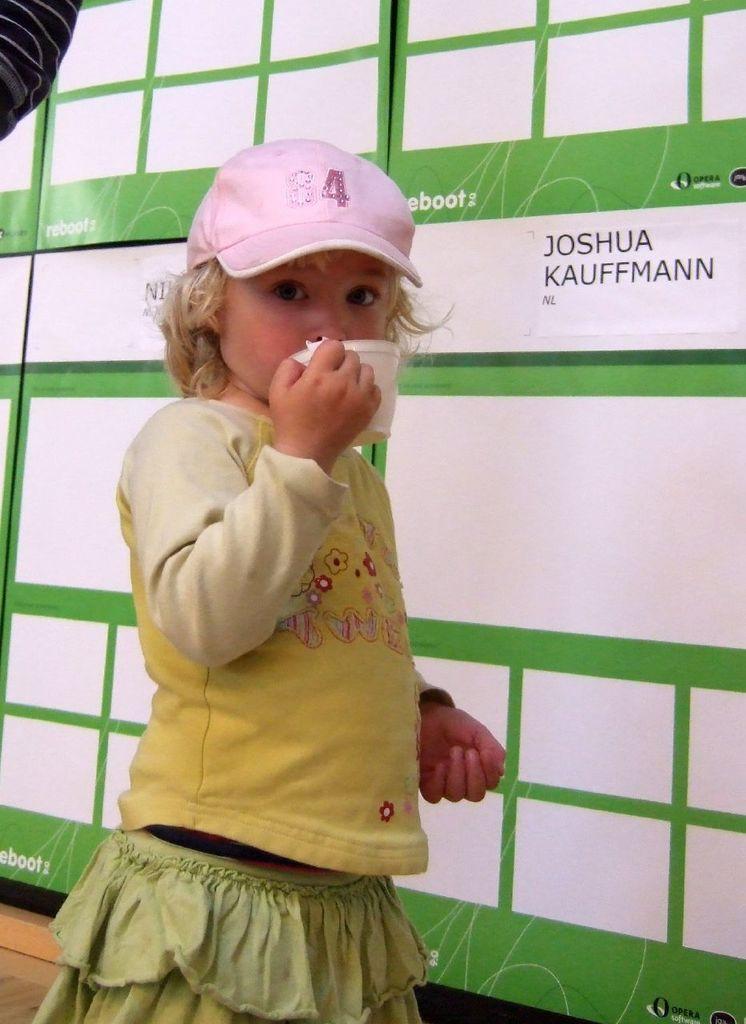In one or two sentences, can you explain what this image depicts? In this image I can see a girl and I can see she is wearing yellow colour dress and pink cap. I can also see she is holding a white colour cup. In the background I can see white and green colour board. On this board I can see something is written. 